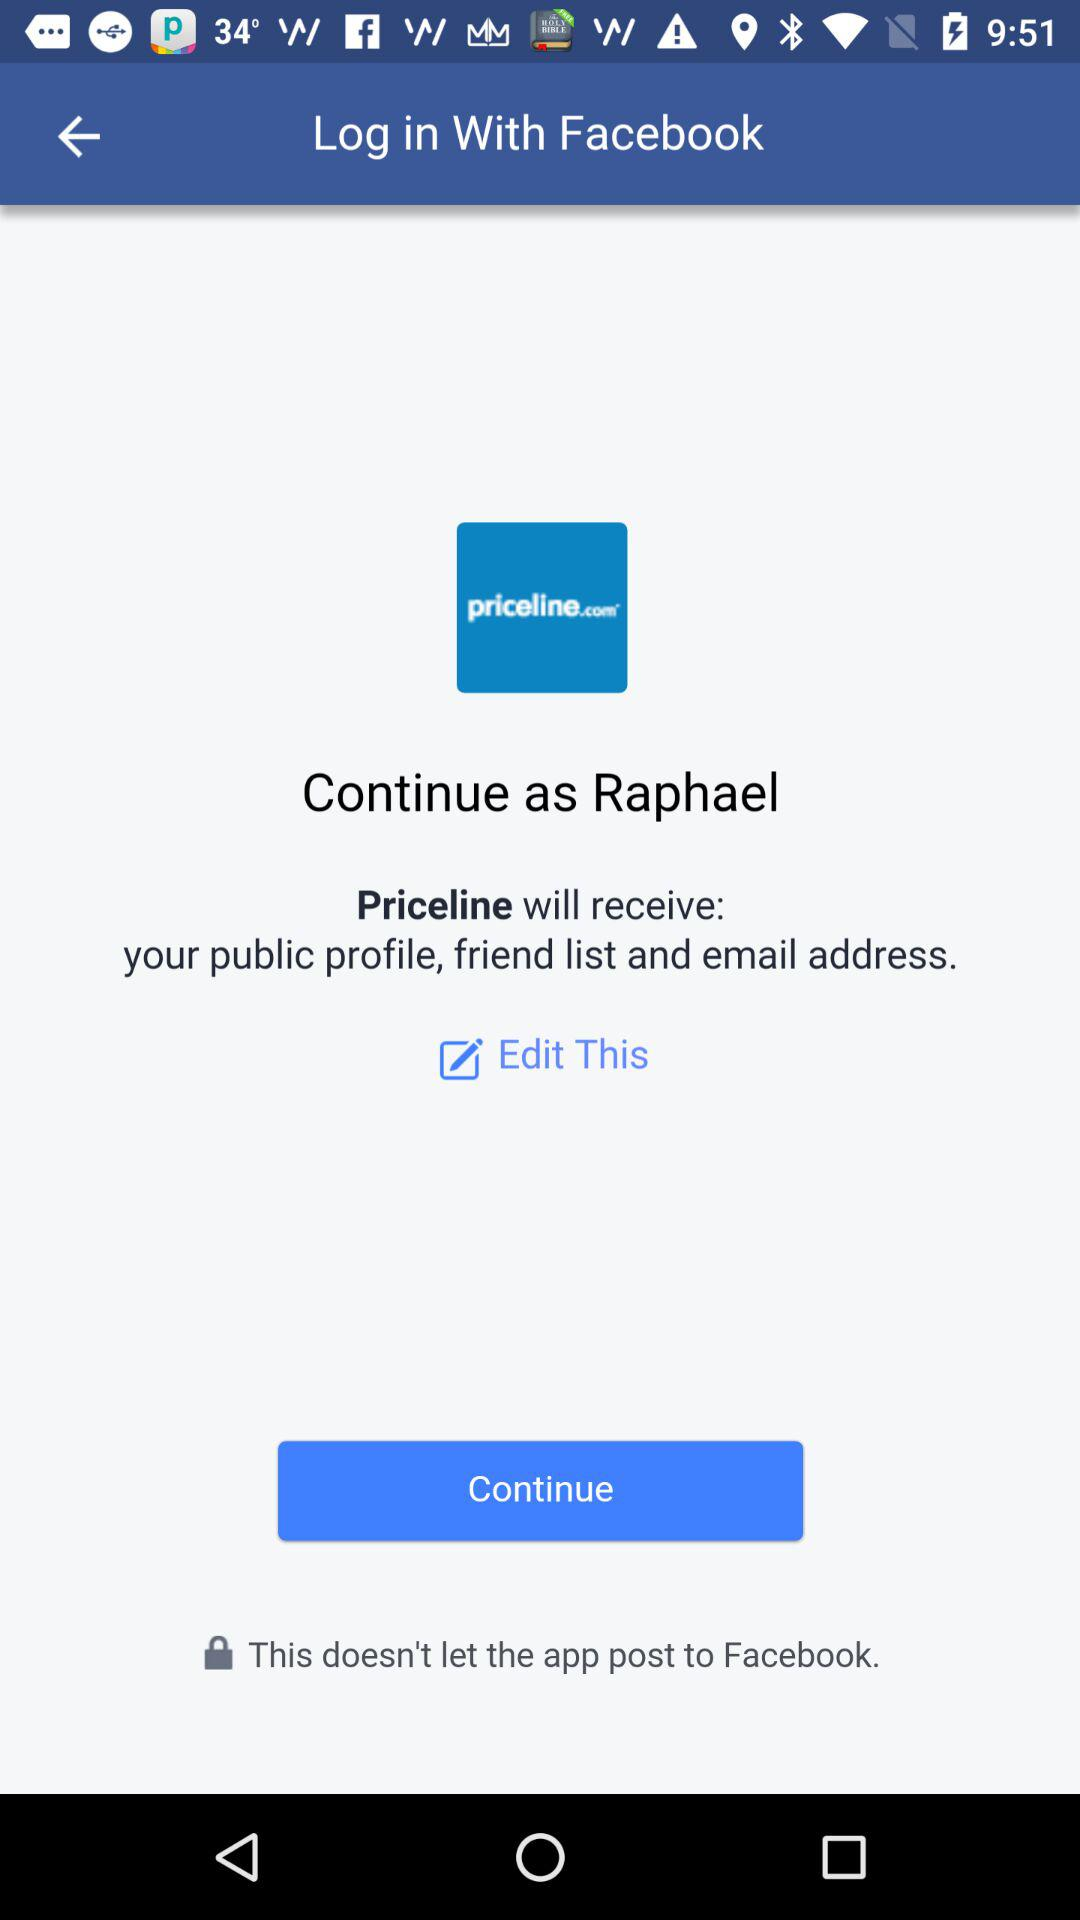What application can be used for log in? The application is "Facebook". 